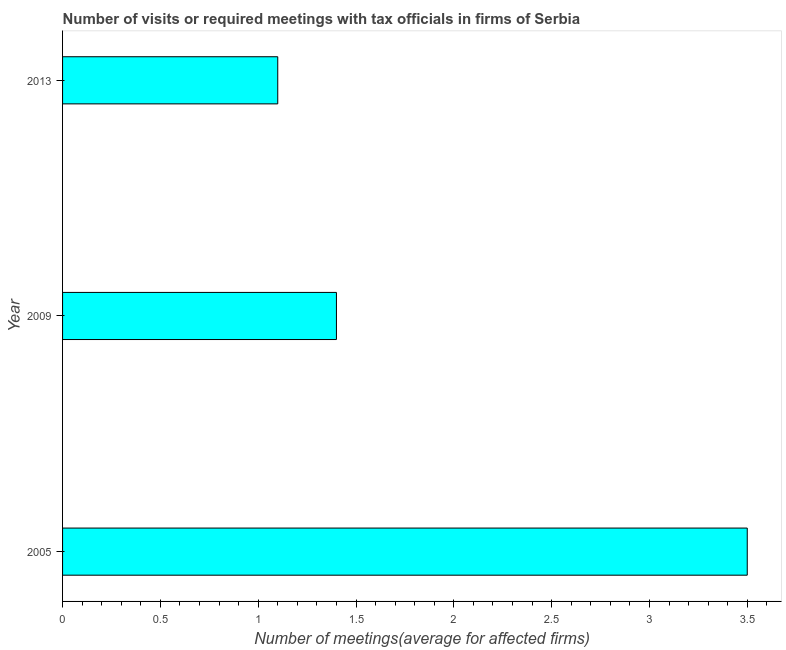What is the title of the graph?
Offer a terse response. Number of visits or required meetings with tax officials in firms of Serbia. What is the label or title of the X-axis?
Offer a terse response. Number of meetings(average for affected firms). What is the label or title of the Y-axis?
Make the answer very short. Year. Across all years, what is the minimum number of required meetings with tax officials?
Give a very brief answer. 1.1. In which year was the number of required meetings with tax officials maximum?
Give a very brief answer. 2005. In which year was the number of required meetings with tax officials minimum?
Make the answer very short. 2013. What is the sum of the number of required meetings with tax officials?
Offer a terse response. 6. What is the difference between the number of required meetings with tax officials in 2005 and 2009?
Your response must be concise. 2.1. What is the average number of required meetings with tax officials per year?
Keep it short and to the point. 2. What is the median number of required meetings with tax officials?
Provide a succinct answer. 1.4. What is the ratio of the number of required meetings with tax officials in 2009 to that in 2013?
Provide a succinct answer. 1.27. Is the number of required meetings with tax officials in 2009 less than that in 2013?
Ensure brevity in your answer.  No. Is the difference between the number of required meetings with tax officials in 2005 and 2013 greater than the difference between any two years?
Offer a terse response. Yes. Is the sum of the number of required meetings with tax officials in 2005 and 2013 greater than the maximum number of required meetings with tax officials across all years?
Your response must be concise. Yes. What is the difference between the highest and the lowest number of required meetings with tax officials?
Make the answer very short. 2.4. In how many years, is the number of required meetings with tax officials greater than the average number of required meetings with tax officials taken over all years?
Make the answer very short. 1. How many bars are there?
Your answer should be very brief. 3. Are all the bars in the graph horizontal?
Your answer should be very brief. Yes. How many years are there in the graph?
Keep it short and to the point. 3. Are the values on the major ticks of X-axis written in scientific E-notation?
Ensure brevity in your answer.  No. What is the Number of meetings(average for affected firms) in 2013?
Provide a short and direct response. 1.1. What is the difference between the Number of meetings(average for affected firms) in 2005 and 2013?
Offer a very short reply. 2.4. What is the ratio of the Number of meetings(average for affected firms) in 2005 to that in 2009?
Your answer should be compact. 2.5. What is the ratio of the Number of meetings(average for affected firms) in 2005 to that in 2013?
Keep it short and to the point. 3.18. What is the ratio of the Number of meetings(average for affected firms) in 2009 to that in 2013?
Offer a terse response. 1.27. 